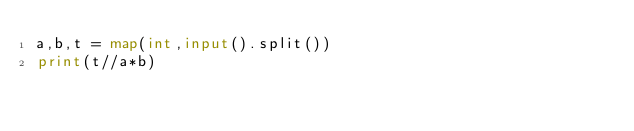<code> <loc_0><loc_0><loc_500><loc_500><_Python_>a,b,t = map(int,input().split())
print(t//a*b)</code> 